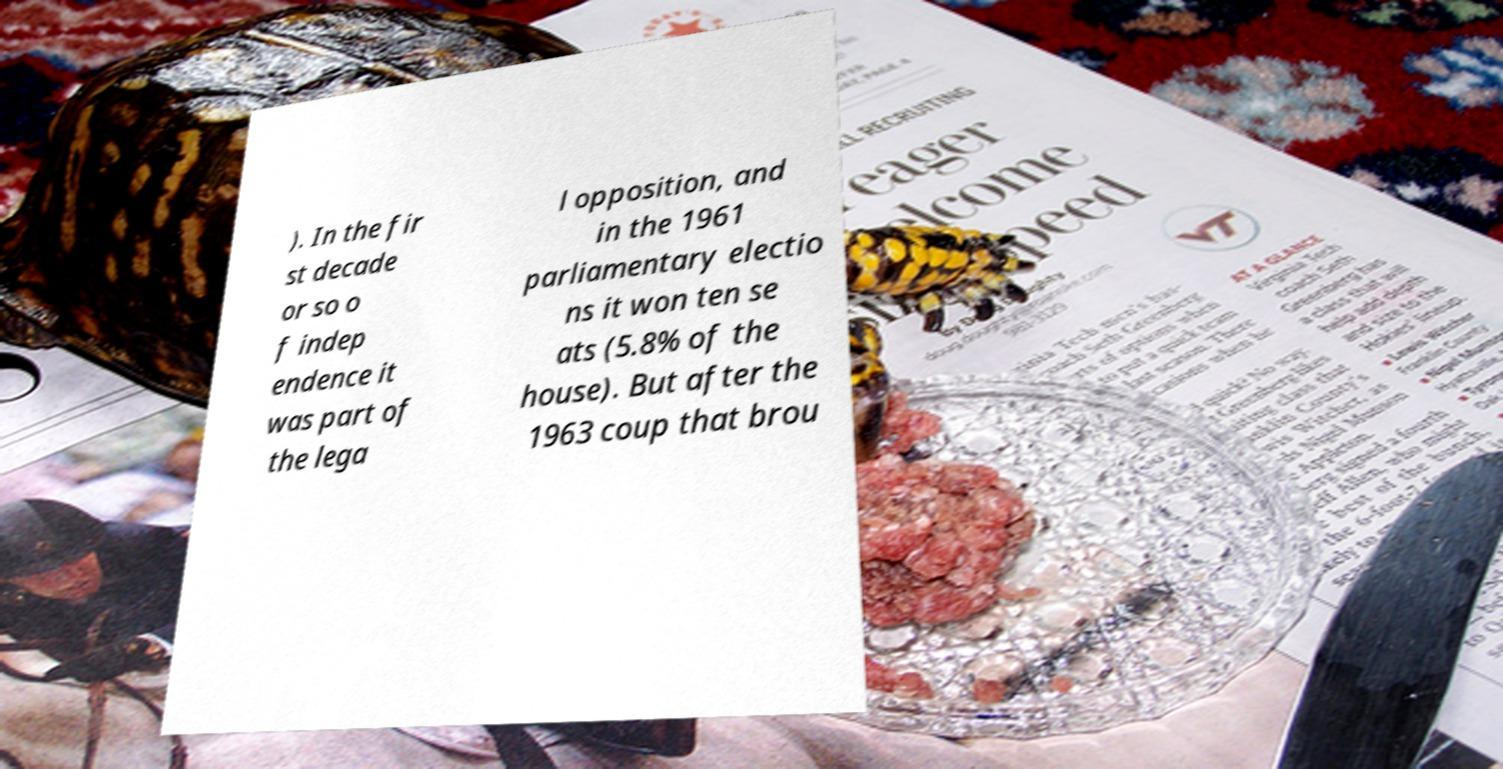Can you read and provide the text displayed in the image?This photo seems to have some interesting text. Can you extract and type it out for me? ). In the fir st decade or so o f indep endence it was part of the lega l opposition, and in the 1961 parliamentary electio ns it won ten se ats (5.8% of the house). But after the 1963 coup that brou 